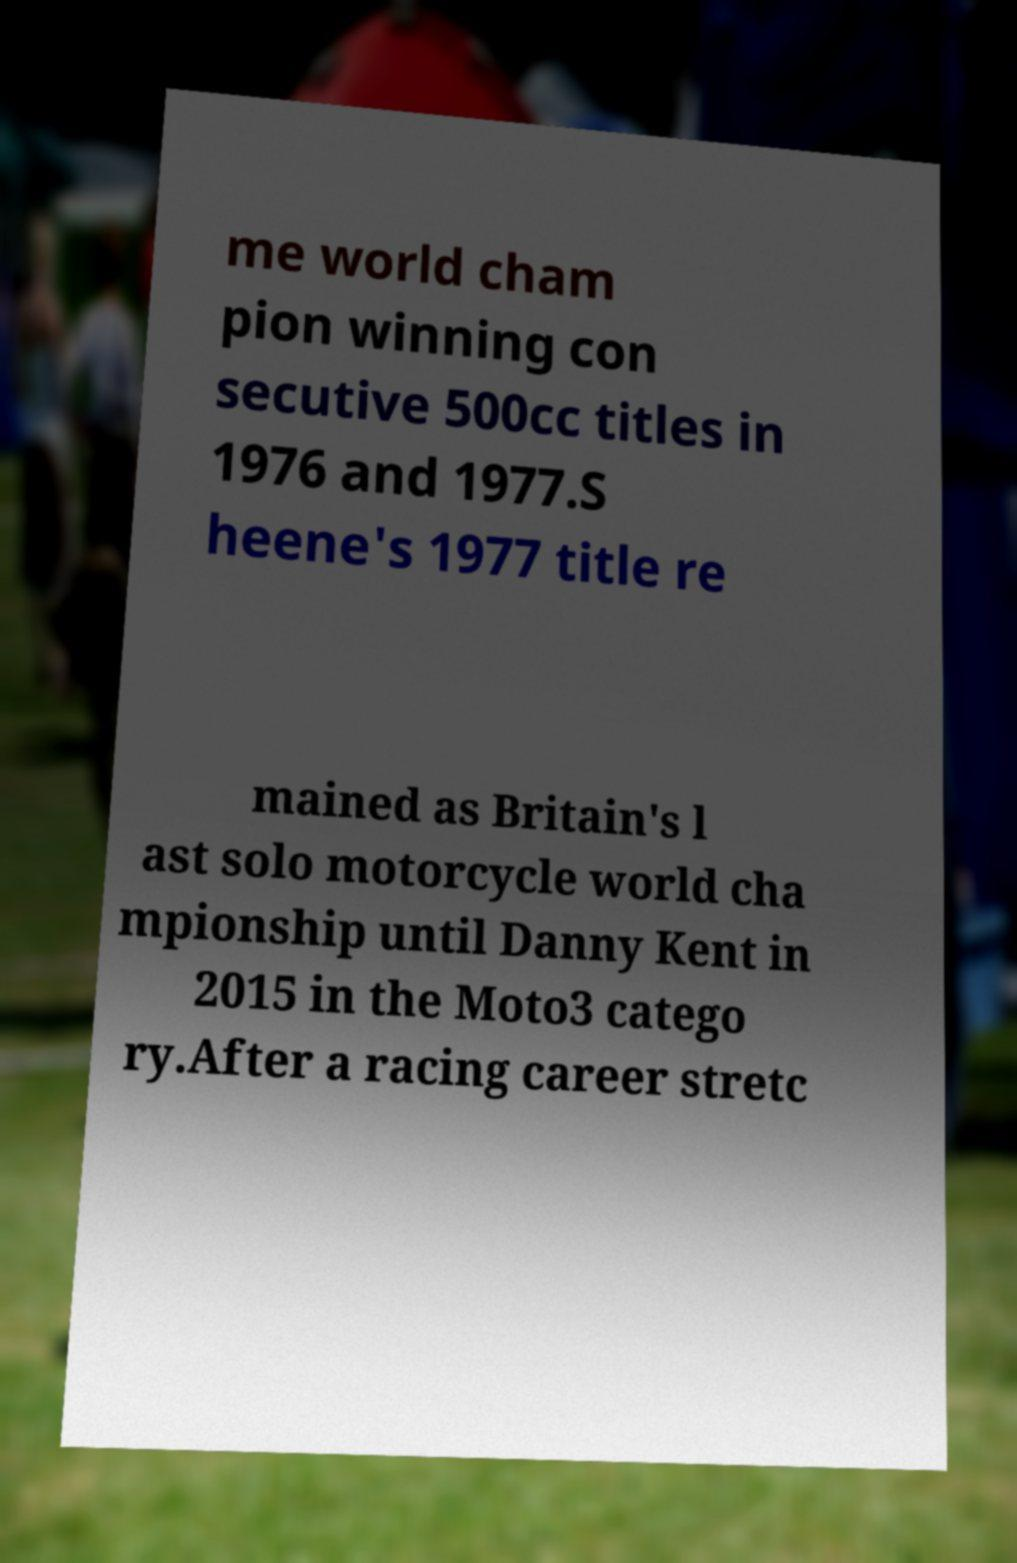I need the written content from this picture converted into text. Can you do that? me world cham pion winning con secutive 500cc titles in 1976 and 1977.S heene's 1977 title re mained as Britain's l ast solo motorcycle world cha mpionship until Danny Kent in 2015 in the Moto3 catego ry.After a racing career stretc 